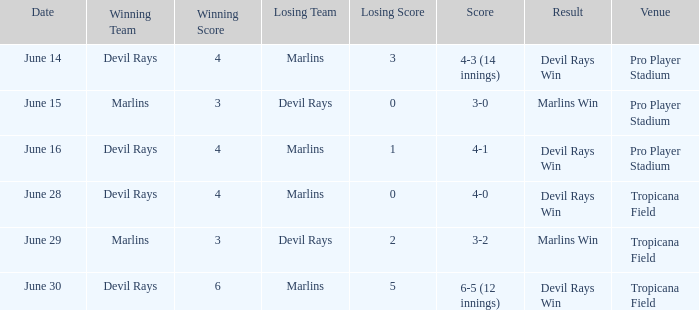On june 14, what was the winning score by the devil rays in pro player stadium? 4-3 (14 innings). 